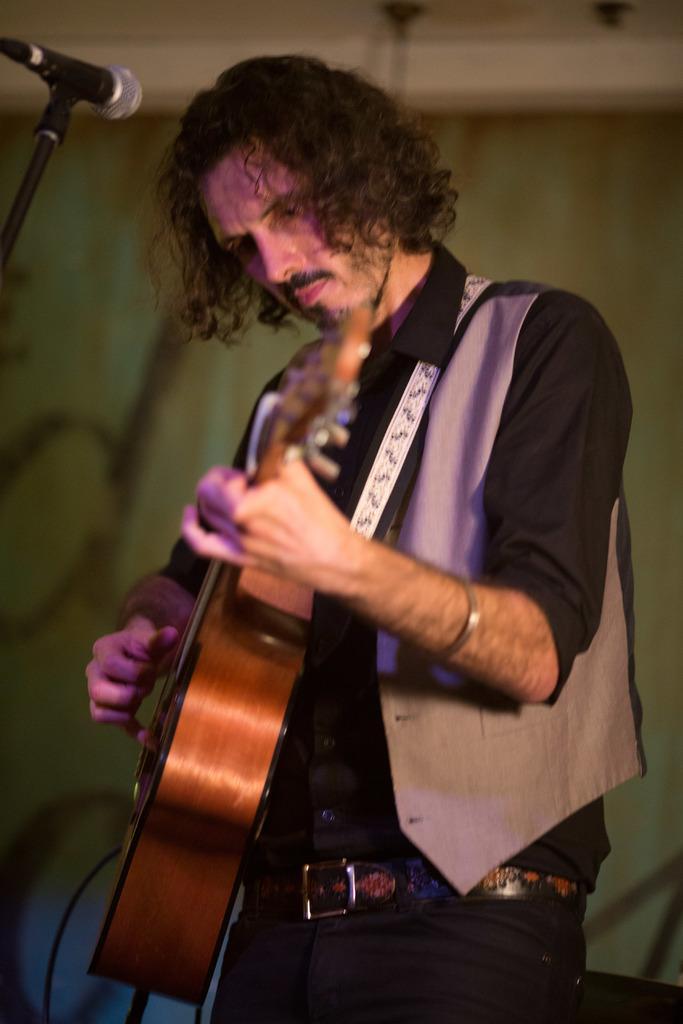In one or two sentences, can you explain what this image depicts? This is the picture of a man standing and playing a guitar and in back ground there is a microphone. 